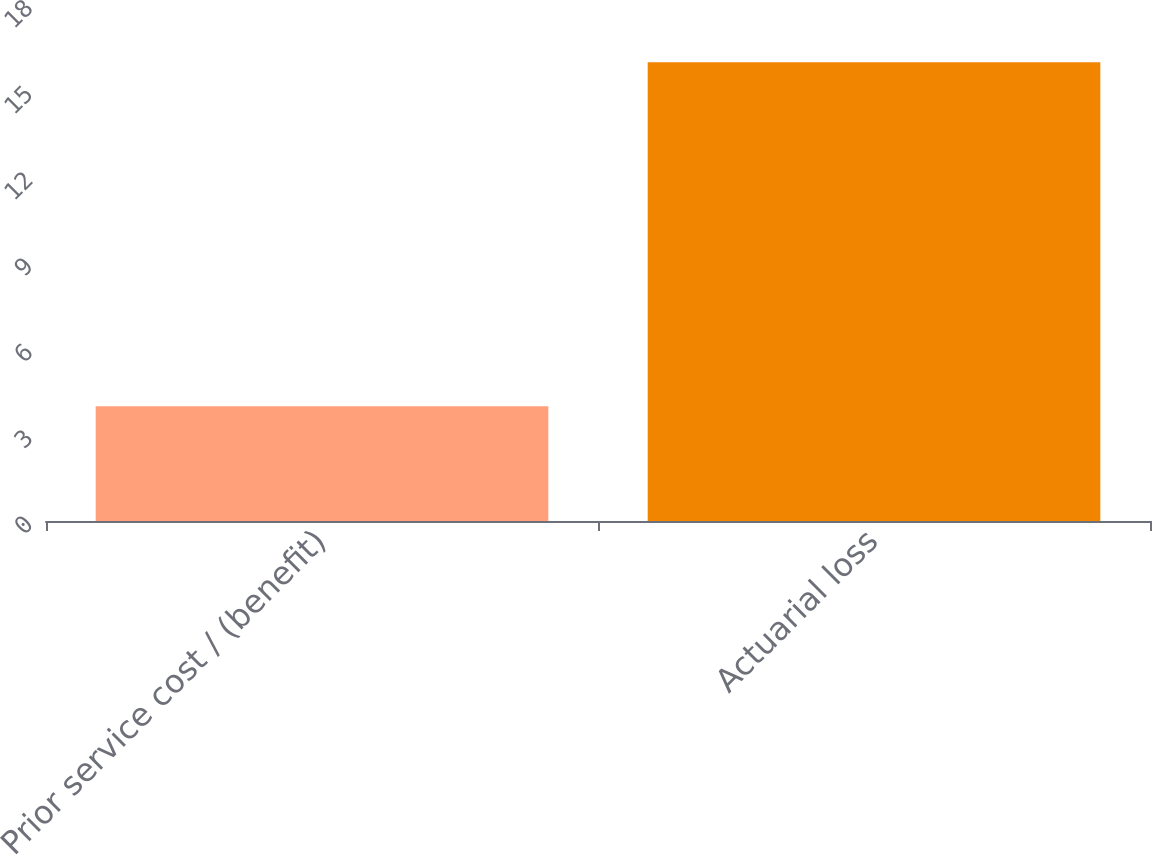Convert chart to OTSL. <chart><loc_0><loc_0><loc_500><loc_500><bar_chart><fcel>Prior service cost / (benefit)<fcel>Actuarial loss<nl><fcel>4<fcel>16<nl></chart> 